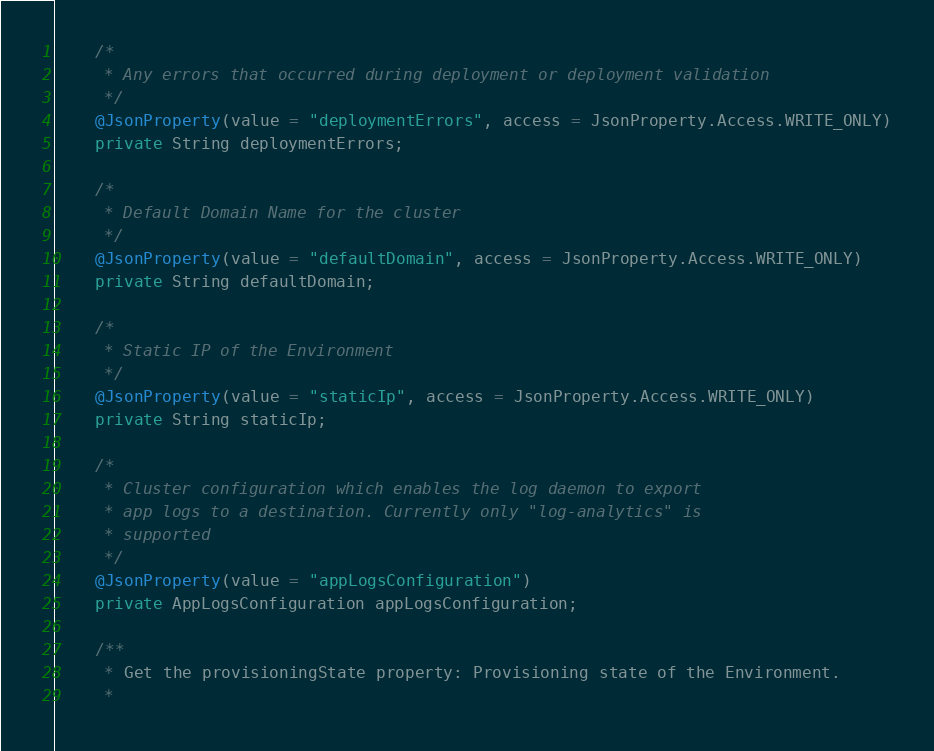<code> <loc_0><loc_0><loc_500><loc_500><_Java_>    /*
     * Any errors that occurred during deployment or deployment validation
     */
    @JsonProperty(value = "deploymentErrors", access = JsonProperty.Access.WRITE_ONLY)
    private String deploymentErrors;

    /*
     * Default Domain Name for the cluster
     */
    @JsonProperty(value = "defaultDomain", access = JsonProperty.Access.WRITE_ONLY)
    private String defaultDomain;

    /*
     * Static IP of the Environment
     */
    @JsonProperty(value = "staticIp", access = JsonProperty.Access.WRITE_ONLY)
    private String staticIp;

    /*
     * Cluster configuration which enables the log daemon to export
     * app logs to a destination. Currently only "log-analytics" is
     * supported
     */
    @JsonProperty(value = "appLogsConfiguration")
    private AppLogsConfiguration appLogsConfiguration;

    /**
     * Get the provisioningState property: Provisioning state of the Environment.
     *</code> 